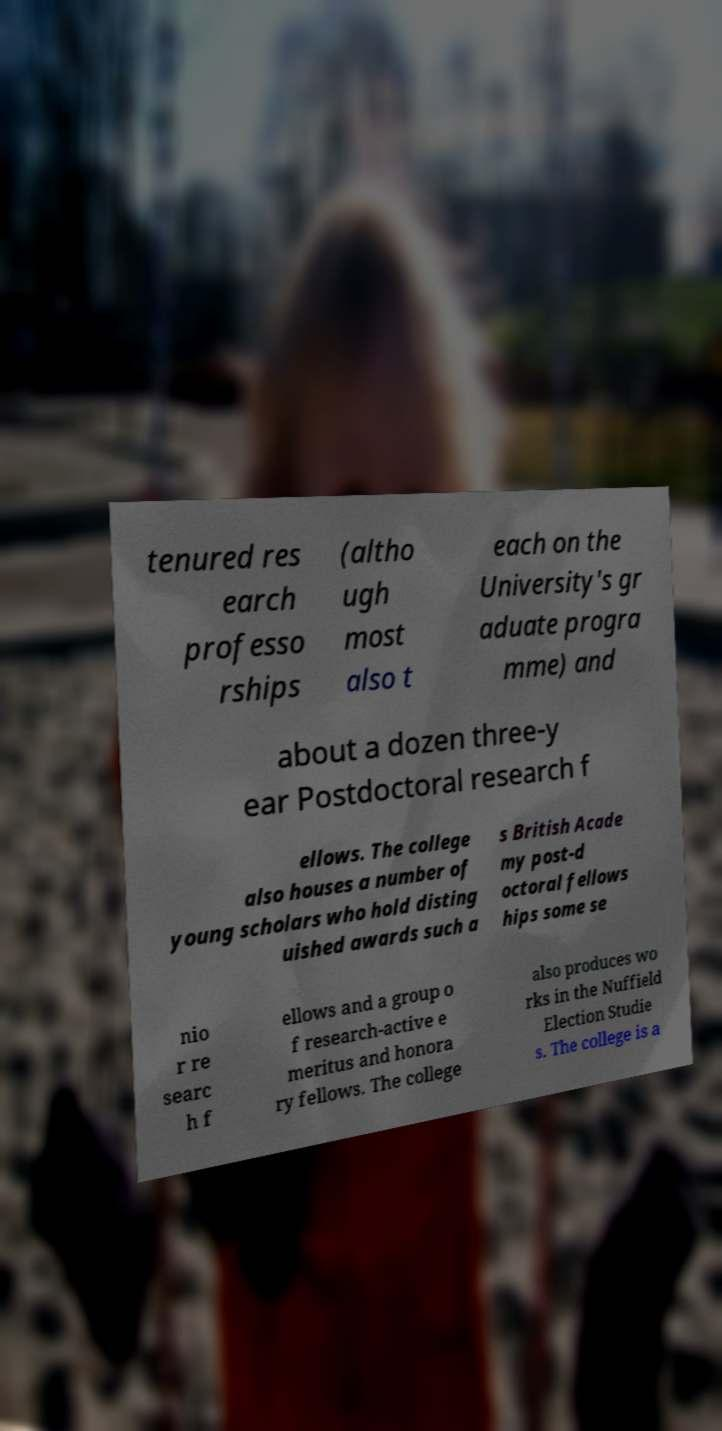Could you extract and type out the text from this image? tenured res earch professo rships (altho ugh most also t each on the University's gr aduate progra mme) and about a dozen three-y ear Postdoctoral research f ellows. The college also houses a number of young scholars who hold disting uished awards such a s British Acade my post-d octoral fellows hips some se nio r re searc h f ellows and a group o f research-active e meritus and honora ry fellows. The college also produces wo rks in the Nuffield Election Studie s. The college is a 